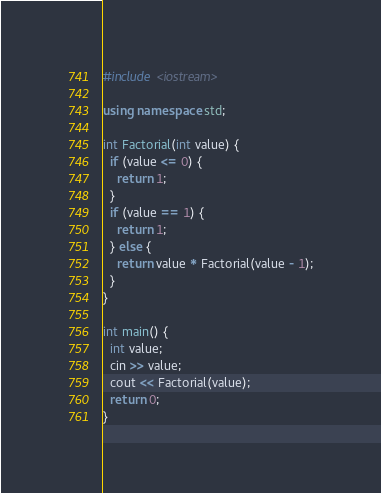Convert code to text. <code><loc_0><loc_0><loc_500><loc_500><_C++_>#include <iostream>

using namespace std;

int Factorial(int value) {
  if (value <= 0) {
    return 1;
  }
  if (value == 1) {
    return 1;
  } else {
    return value * Factorial(value - 1);
  }
}

int main() {
  int value;
  cin >> value;
  cout << Factorial(value);
  return 0;
}</code> 